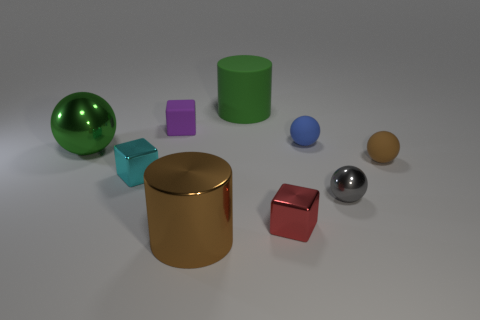What number of big things are either cyan blocks or objects?
Your answer should be compact. 3. What is the material of the big sphere that is the same color as the rubber cylinder?
Your answer should be very brief. Metal. Is there a small brown ball made of the same material as the large green cylinder?
Offer a very short reply. Yes. There is a matte object that is in front of the green shiny thing; is its size the same as the cyan metallic object?
Provide a succinct answer. Yes. Are there any green cylinders in front of the large cylinder that is on the right side of the cylinder that is in front of the tiny brown sphere?
Offer a terse response. No. What number of metal objects are either blue balls or big blue blocks?
Give a very brief answer. 0. What number of other things are there of the same shape as the small cyan object?
Offer a terse response. 2. Is the number of small metal things greater than the number of big cylinders?
Keep it short and to the point. Yes. How big is the cube behind the metal cube that is to the left of the big metallic object that is in front of the big green shiny thing?
Make the answer very short. Small. There is a brown thing to the left of the red thing; what is its size?
Ensure brevity in your answer.  Large. 